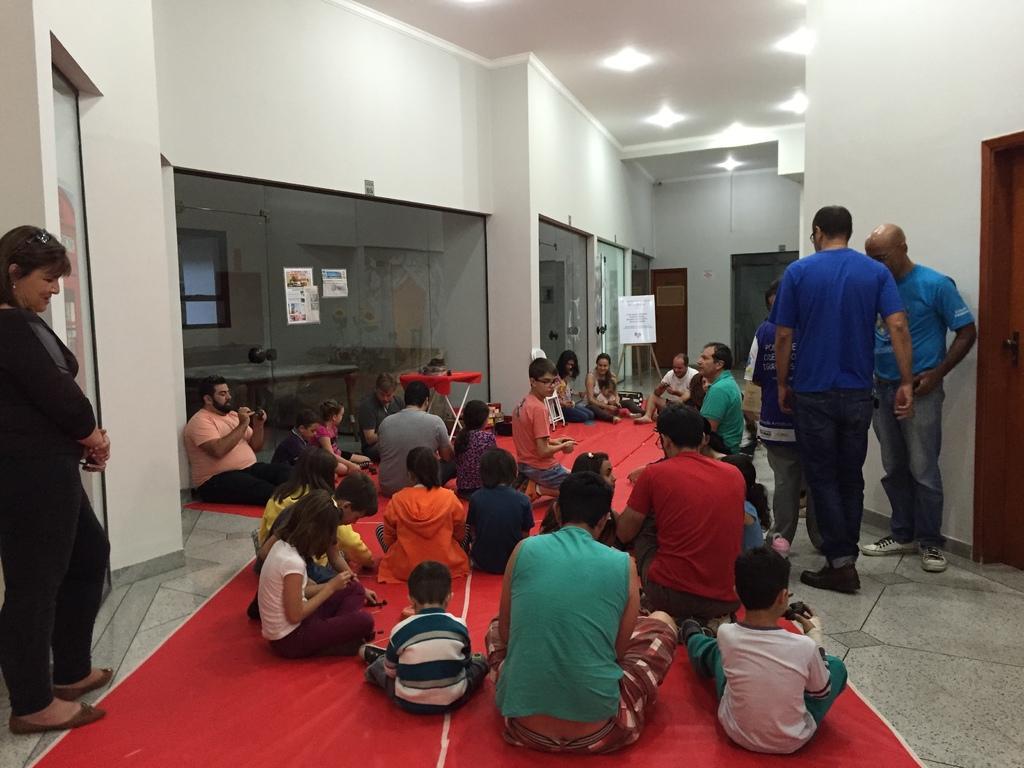In one or two sentences, can you explain what this image depicts? In this picture we can see a group of people, cloth on the ground, some people are standing, some people are sitting on a cloth, here we can see posters, wall and some objects and in the background we can see a roof, lights. 